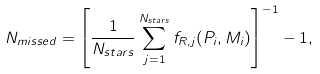<formula> <loc_0><loc_0><loc_500><loc_500>N _ { m i s s e d } = \left [ \frac { 1 } { N _ { s t a r s } } \sum _ { j = 1 } ^ { N _ { s t a r s } } f _ { R , j } ( P _ { i } , M _ { i } ) \right ] ^ { - 1 } - 1 ,</formula> 